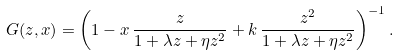<formula> <loc_0><loc_0><loc_500><loc_500>G ( z , x ) = \left ( 1 - x \, \frac { z } { 1 + \lambda z + \eta z ^ { 2 } } + k \, \frac { z ^ { 2 } } { 1 + \lambda z + \eta z ^ { 2 } } \right ) ^ { - 1 } .</formula> 